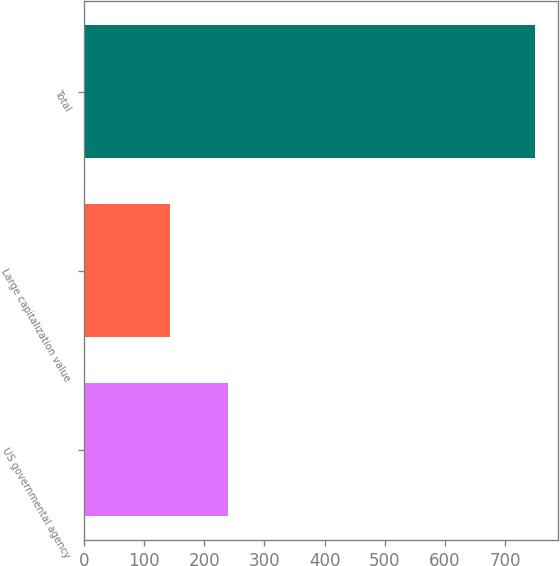Convert chart. <chart><loc_0><loc_0><loc_500><loc_500><bar_chart><fcel>US governmental agency<fcel>Large capitalization value<fcel>Total<nl><fcel>239<fcel>143<fcel>750<nl></chart> 